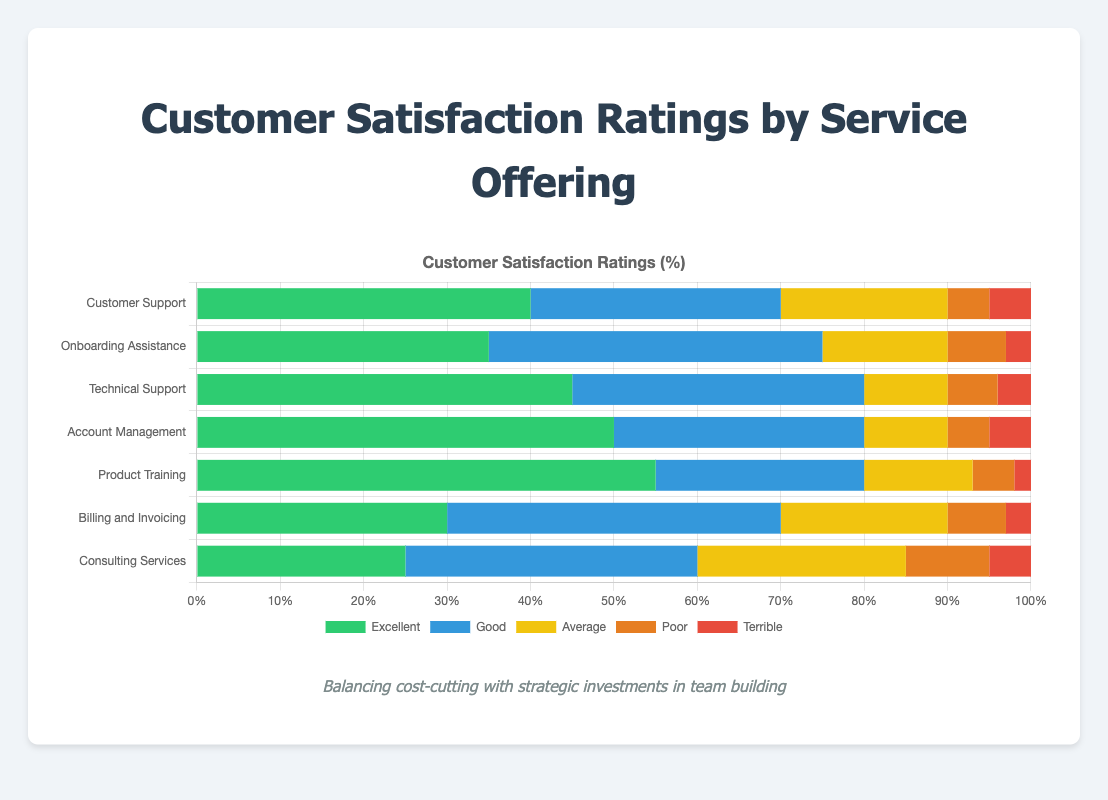What is the total percentage of ratings that are either "Poor" or "Terrible" for Account Management? To find the total percentage of ratings that are either "Poor" or "Terrible" for Account Management, add the percentages of "Poor" and "Terrible" ratings. "Poor" is 5% and "Terrible" is 5%. So, 5% + 5% = 10%.
Answer: 10% Which service offering has the highest percentage of "Excellent" ratings? By comparing the "Excellent" ratings across all service offerings, we can see that Product Training has the highest percentage at 55%.
Answer: Product Training Do Billing and Invoicing have a higher percentage of "Average" ratings than Consulting Services? Compare the "Average" ratings of Billing and Invoicing (20%) with Consulting Services (25%). Consulting Services have a higher percentage.
Answer: No What is the combined percentage of ratings that are "Excellent" or "Good" for Technical Support? To find the combined percentage of "Excellent" and "Good" ratings for Technical Support, add the percentages of "Excellent" (45%) and "Good" (35%). Thus, 45% + 35% = 80%.
Answer: 80% Which service has the lowest percentage of "Terrible" ratings and what is that percentage? By comparing the "Terrible" percentages across all services, we can see that Product Training has the lowest percentage at 2%.
Answer: Product Training, 2% How does the percentage of "Average" ratings for Onboarding Assistance compare to that for Customer Support? Compare the "Average" ratings for Onboarding Assistance (15%) with Customer Support (20%). Onboarding Assistance has a lower percentage.
Answer: Lower For which service is the combined percentage of "Poor" and "Terrible" ratings the highest, and what is that percentage? Adding "Poor" and "Terrible" percentages, we see Consulting Services has "Poor" (10%) and "Terrible" (5%), totaling 15%. This is the highest combined percentage among all services.
Answer: Consulting Services, 15% Which service has the longest "Good" rating bar in the chart? The "Good" rating bar that stretches the farthest belongs to Billing and Invoicing, with 40%
Answer: Billing and Invoicing Among all services, which one has the lowest combined percentage of "Excellent" and "Good" ratings? To find the service with the lowest combined "Excellent" and "Good" ratings, sum these percentages for each service. Consulting Services: 25% (Excellent) + 35% (Good) = 60%, which is the lowest.
Answer: Consulting Services Is the percentage of "Excellent" ratings higher for Customer Support or Technical Support? Compare the "Excellent" ratings for Customer Support (40%) with Technical Support (45%). Technical Support has a higher percentage.
Answer: Technical Support 